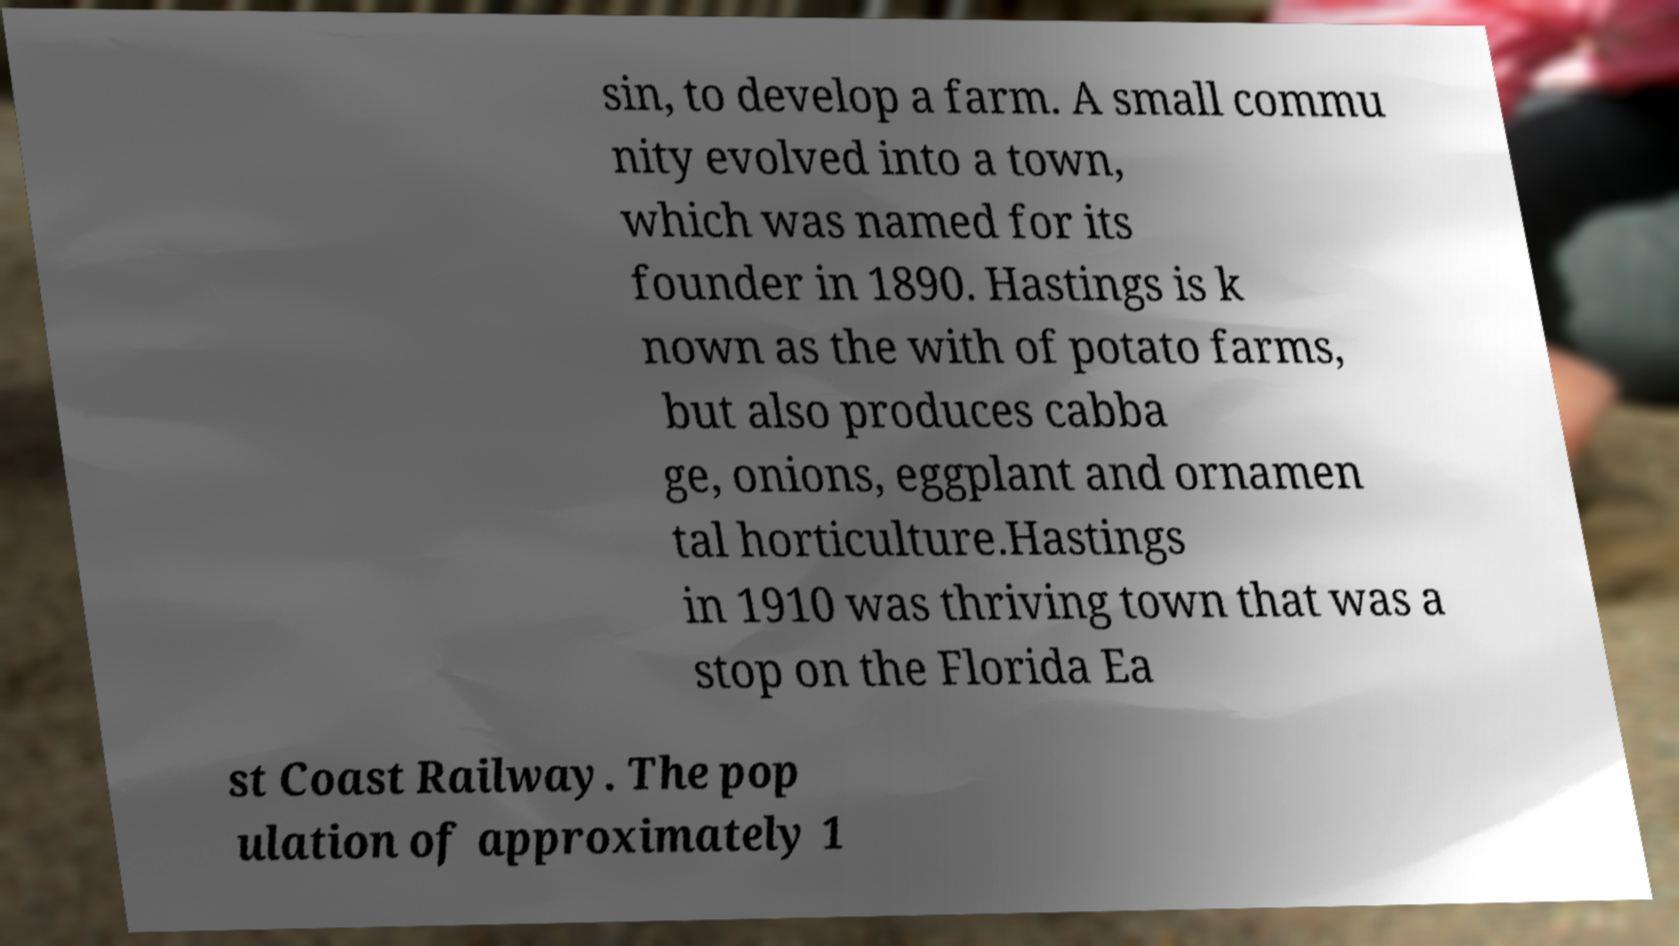What messages or text are displayed in this image? I need them in a readable, typed format. sin, to develop a farm. A small commu nity evolved into a town, which was named for its founder in 1890. Hastings is k nown as the with of potato farms, but also produces cabba ge, onions, eggplant and ornamen tal horticulture.Hastings in 1910 was thriving town that was a stop on the Florida Ea st Coast Railway. The pop ulation of approximately 1 